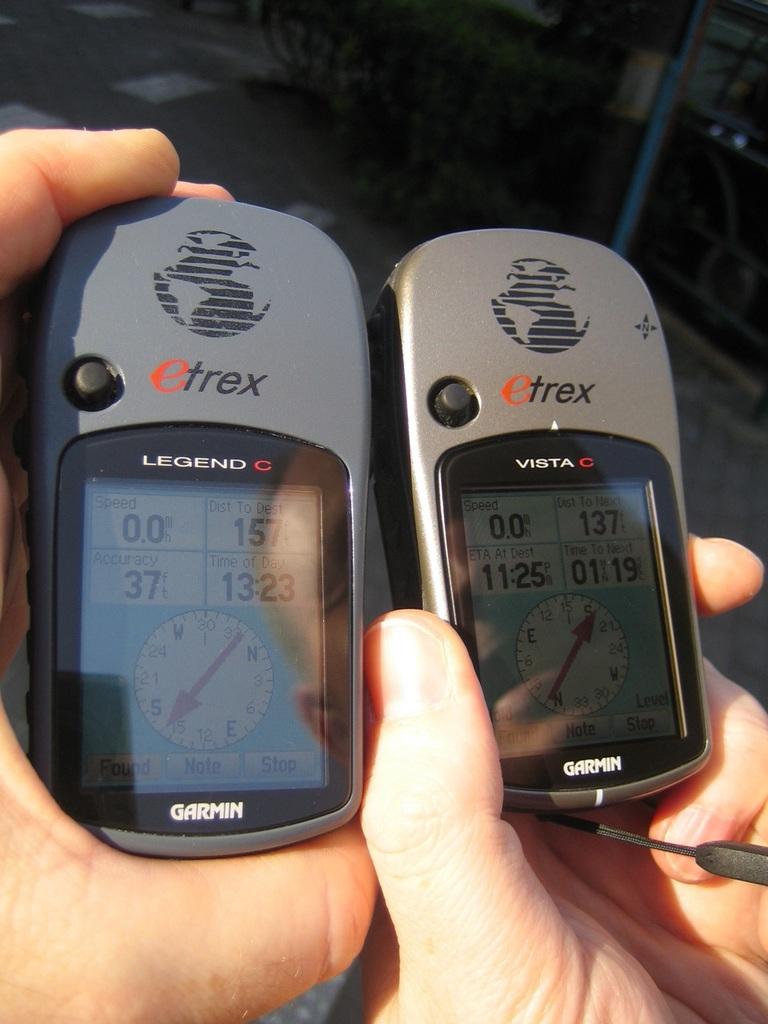What company made these devices?
Offer a terse response. Etrex. What model of device are these?
Your response must be concise. Etrex. 